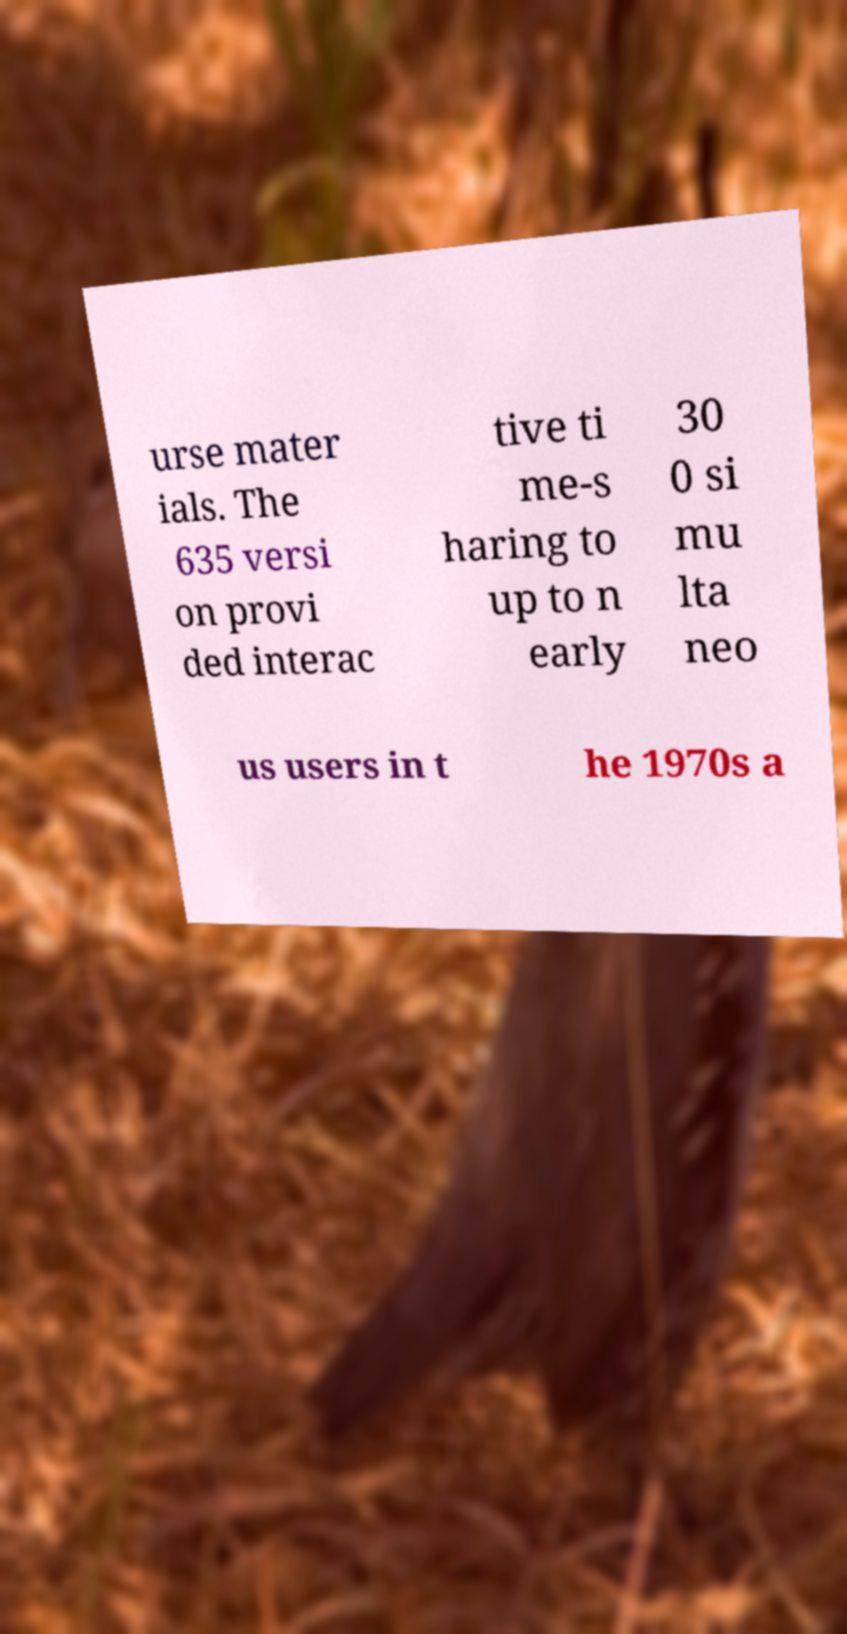Can you read and provide the text displayed in the image?This photo seems to have some interesting text. Can you extract and type it out for me? urse mater ials. The 635 versi on provi ded interac tive ti me-s haring to up to n early 30 0 si mu lta neo us users in t he 1970s a 